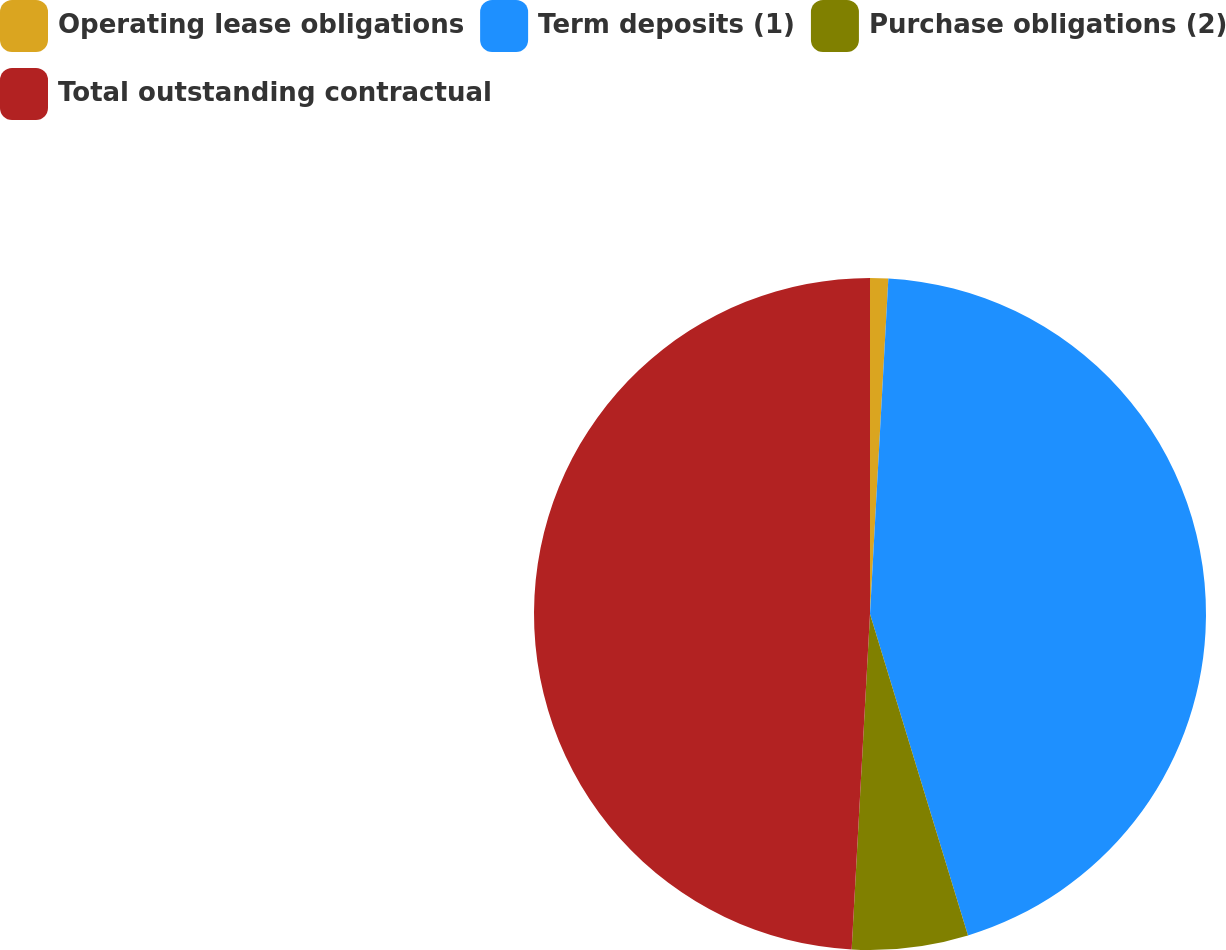<chart> <loc_0><loc_0><loc_500><loc_500><pie_chart><fcel>Operating lease obligations<fcel>Term deposits (1)<fcel>Purchase obligations (2)<fcel>Total outstanding contractual<nl><fcel>0.87%<fcel>44.42%<fcel>5.58%<fcel>49.13%<nl></chart> 